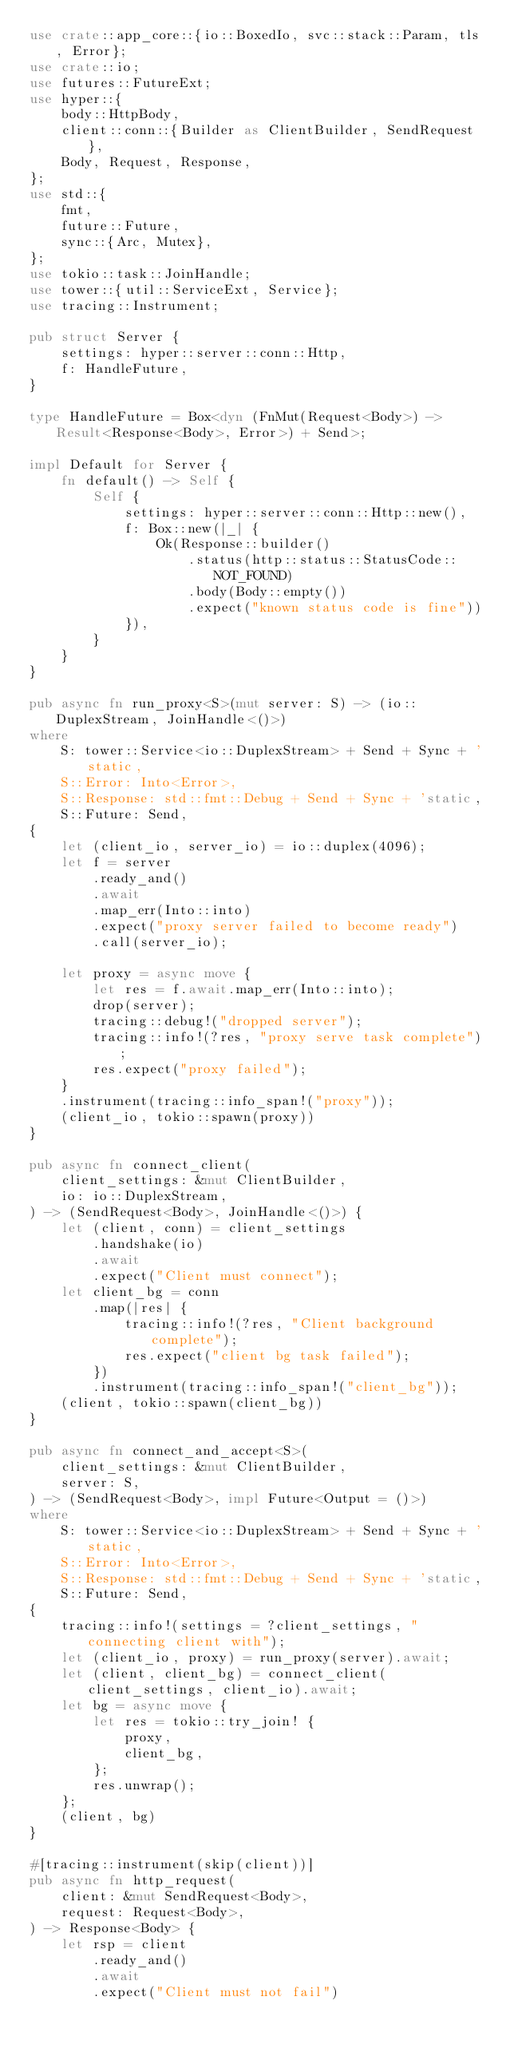<code> <loc_0><loc_0><loc_500><loc_500><_Rust_>use crate::app_core::{io::BoxedIo, svc::stack::Param, tls, Error};
use crate::io;
use futures::FutureExt;
use hyper::{
    body::HttpBody,
    client::conn::{Builder as ClientBuilder, SendRequest},
    Body, Request, Response,
};
use std::{
    fmt,
    future::Future,
    sync::{Arc, Mutex},
};
use tokio::task::JoinHandle;
use tower::{util::ServiceExt, Service};
use tracing::Instrument;

pub struct Server {
    settings: hyper::server::conn::Http,
    f: HandleFuture,
}

type HandleFuture = Box<dyn (FnMut(Request<Body>) -> Result<Response<Body>, Error>) + Send>;

impl Default for Server {
    fn default() -> Self {
        Self {
            settings: hyper::server::conn::Http::new(),
            f: Box::new(|_| {
                Ok(Response::builder()
                    .status(http::status::StatusCode::NOT_FOUND)
                    .body(Body::empty())
                    .expect("known status code is fine"))
            }),
        }
    }
}

pub async fn run_proxy<S>(mut server: S) -> (io::DuplexStream, JoinHandle<()>)
where
    S: tower::Service<io::DuplexStream> + Send + Sync + 'static,
    S::Error: Into<Error>,
    S::Response: std::fmt::Debug + Send + Sync + 'static,
    S::Future: Send,
{
    let (client_io, server_io) = io::duplex(4096);
    let f = server
        .ready_and()
        .await
        .map_err(Into::into)
        .expect("proxy server failed to become ready")
        .call(server_io);

    let proxy = async move {
        let res = f.await.map_err(Into::into);
        drop(server);
        tracing::debug!("dropped server");
        tracing::info!(?res, "proxy serve task complete");
        res.expect("proxy failed");
    }
    .instrument(tracing::info_span!("proxy"));
    (client_io, tokio::spawn(proxy))
}

pub async fn connect_client(
    client_settings: &mut ClientBuilder,
    io: io::DuplexStream,
) -> (SendRequest<Body>, JoinHandle<()>) {
    let (client, conn) = client_settings
        .handshake(io)
        .await
        .expect("Client must connect");
    let client_bg = conn
        .map(|res| {
            tracing::info!(?res, "Client background complete");
            res.expect("client bg task failed");
        })
        .instrument(tracing::info_span!("client_bg"));
    (client, tokio::spawn(client_bg))
}

pub async fn connect_and_accept<S>(
    client_settings: &mut ClientBuilder,
    server: S,
) -> (SendRequest<Body>, impl Future<Output = ()>)
where
    S: tower::Service<io::DuplexStream> + Send + Sync + 'static,
    S::Error: Into<Error>,
    S::Response: std::fmt::Debug + Send + Sync + 'static,
    S::Future: Send,
{
    tracing::info!(settings = ?client_settings, "connecting client with");
    let (client_io, proxy) = run_proxy(server).await;
    let (client, client_bg) = connect_client(client_settings, client_io).await;
    let bg = async move {
        let res = tokio::try_join! {
            proxy,
            client_bg,
        };
        res.unwrap();
    };
    (client, bg)
}

#[tracing::instrument(skip(client))]
pub async fn http_request(
    client: &mut SendRequest<Body>,
    request: Request<Body>,
) -> Response<Body> {
    let rsp = client
        .ready_and()
        .await
        .expect("Client must not fail")</code> 